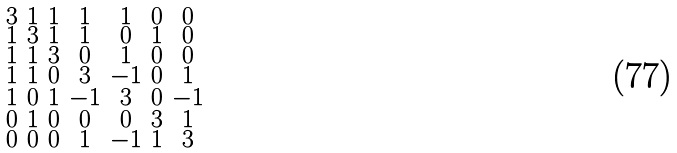Convert formula to latex. <formula><loc_0><loc_0><loc_500><loc_500>\begin{smallmatrix} 3 & 1 & 1 & 1 & 1 & 0 & 0 \\ 1 & 3 & 1 & 1 & 0 & 1 & 0 \\ 1 & 1 & 3 & 0 & 1 & 0 & 0 \\ 1 & 1 & 0 & 3 & - 1 & 0 & 1 \\ 1 & 0 & 1 & - 1 & 3 & 0 & - 1 \\ 0 & 1 & 0 & 0 & 0 & 3 & 1 \\ 0 & 0 & 0 & 1 & - 1 & 1 & 3 \end{smallmatrix}</formula> 